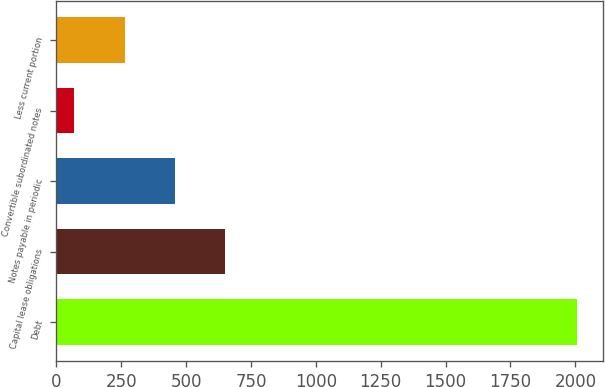Convert chart. <chart><loc_0><loc_0><loc_500><loc_500><bar_chart><fcel>Debt<fcel>Capital lease obligations<fcel>Notes payable in periodic<fcel>Convertible subordinated notes<fcel>Less current portion<nl><fcel>2006<fcel>650.8<fcel>457.2<fcel>70<fcel>263.6<nl></chart> 